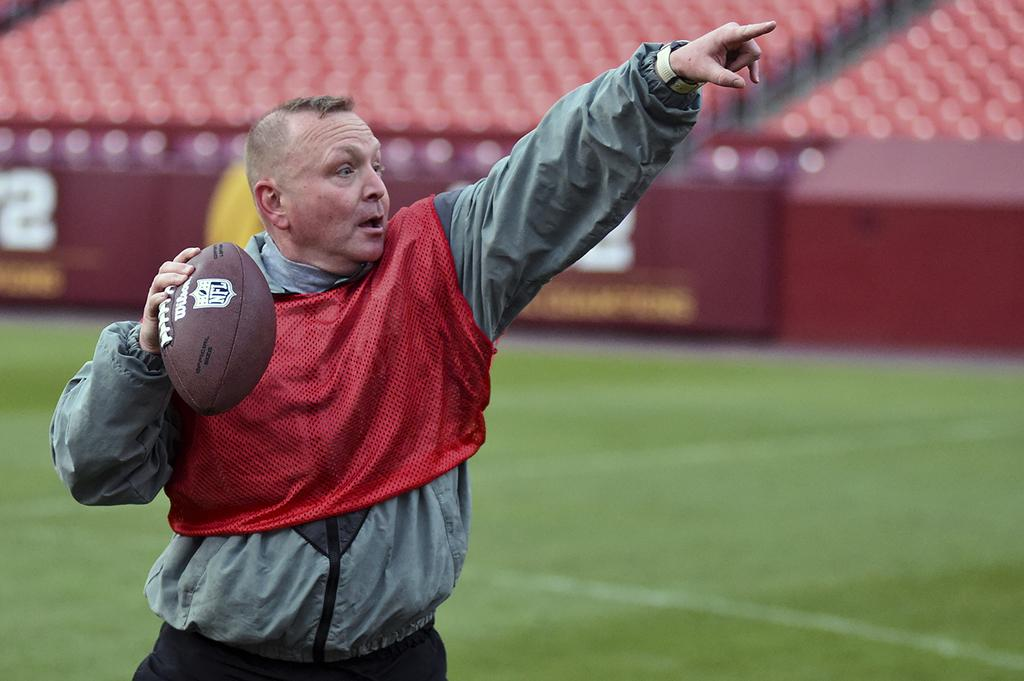Who is present in the image? There is a man in the image. What is the man doing in the image? The man is standing on the ground and holding a soccer ball. What can be seen in the background of the image? There is a fence visible in the image. What objects are present in the image besides the man and the soccer ball? There is a group of chairs in the image. What type of request is the man making to his partner in the image? There is no indication in the image that the man is making a request or has a partner present. 